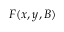<formula> <loc_0><loc_0><loc_500><loc_500>F ( x , y , B )</formula> 